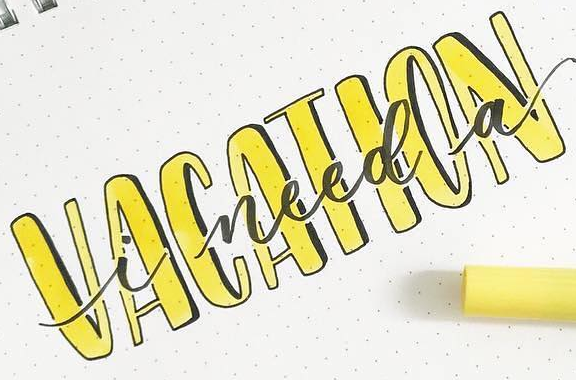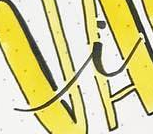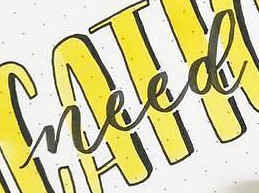Identify the words shown in these images in order, separated by a semicolon. VACATION; i; need 